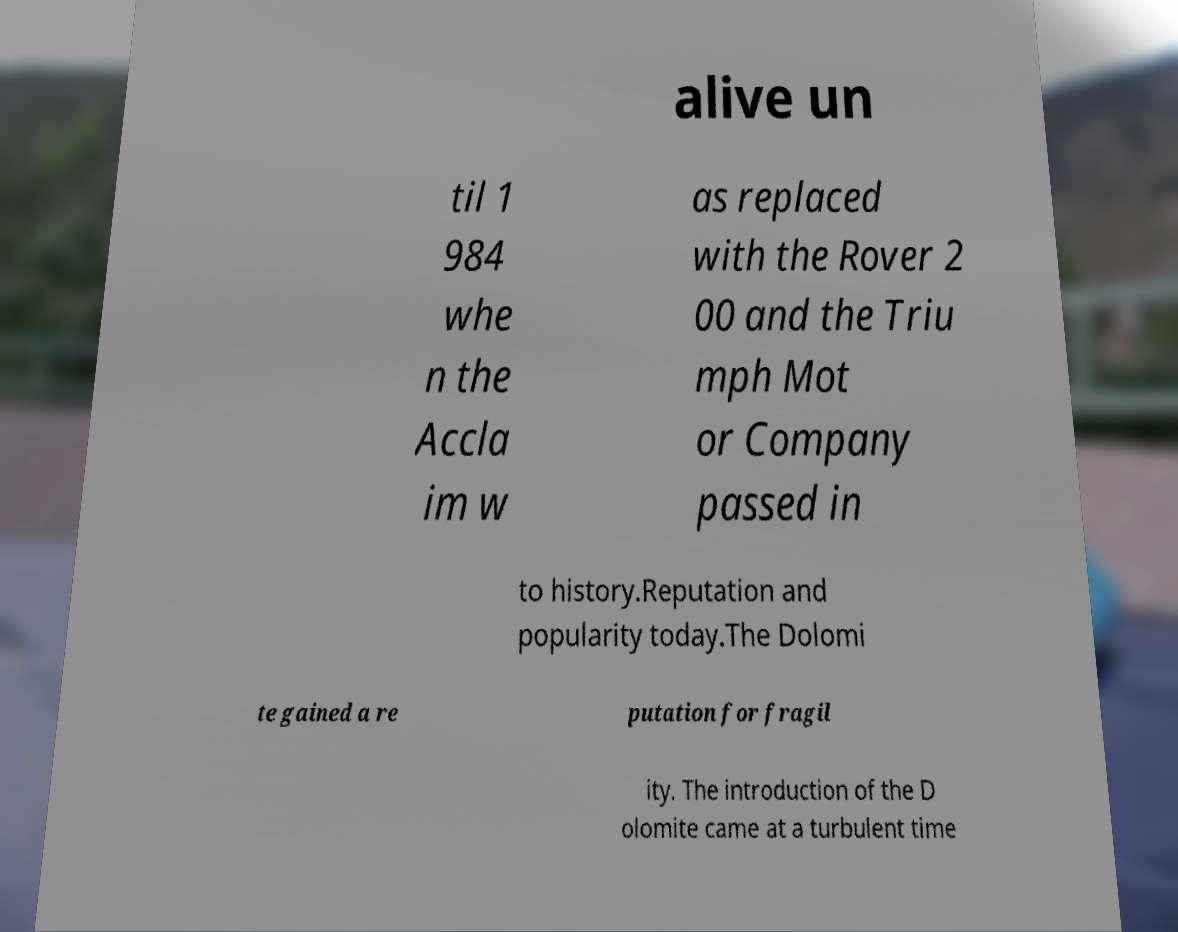There's text embedded in this image that I need extracted. Can you transcribe it verbatim? alive un til 1 984 whe n the Accla im w as replaced with the Rover 2 00 and the Triu mph Mot or Company passed in to history.Reputation and popularity today.The Dolomi te gained a re putation for fragil ity. The introduction of the D olomite came at a turbulent time 